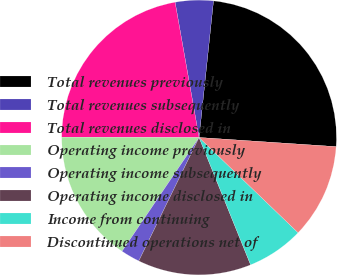Convert chart to OTSL. <chart><loc_0><loc_0><loc_500><loc_500><pie_chart><fcel>Total revenues previously<fcel>Total revenues subsequently<fcel>Total revenues disclosed in<fcel>Operating income previously<fcel>Operating income subsequently<fcel>Operating income disclosed in<fcel>Income from continuing<fcel>Discontinued operations net of<nl><fcel>24.39%<fcel>4.47%<fcel>22.17%<fcel>15.57%<fcel>2.25%<fcel>13.35%<fcel>6.69%<fcel>11.13%<nl></chart> 